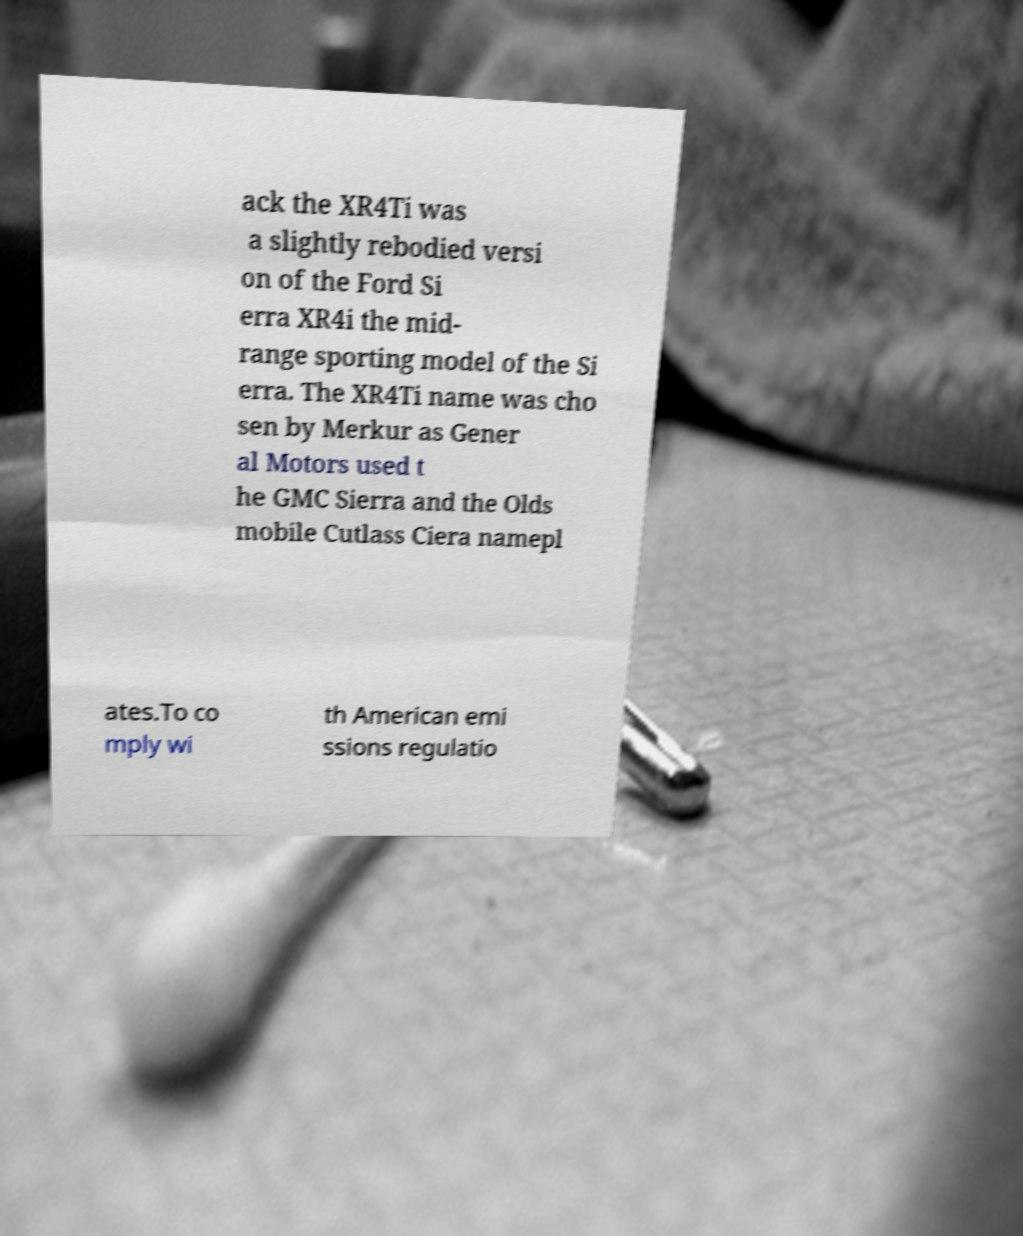I need the written content from this picture converted into text. Can you do that? ack the XR4Ti was a slightly rebodied versi on of the Ford Si erra XR4i the mid- range sporting model of the Si erra. The XR4Ti name was cho sen by Merkur as Gener al Motors used t he GMC Sierra and the Olds mobile Cutlass Ciera namepl ates.To co mply wi th American emi ssions regulatio 